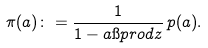<formula> <loc_0><loc_0><loc_500><loc_500>\pi ( a ) \colon = \frac { 1 } { 1 - a \i p r o d z } \, p ( a ) .</formula> 